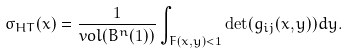<formula> <loc_0><loc_0><loc_500><loc_500>\sigma _ { H T } ( x ) = \frac { 1 } { v o l ( B ^ { n } ( 1 ) ) } \int _ { F ( x , y ) < 1 } \det ( g _ { i j } ( x , y ) ) d y .</formula> 